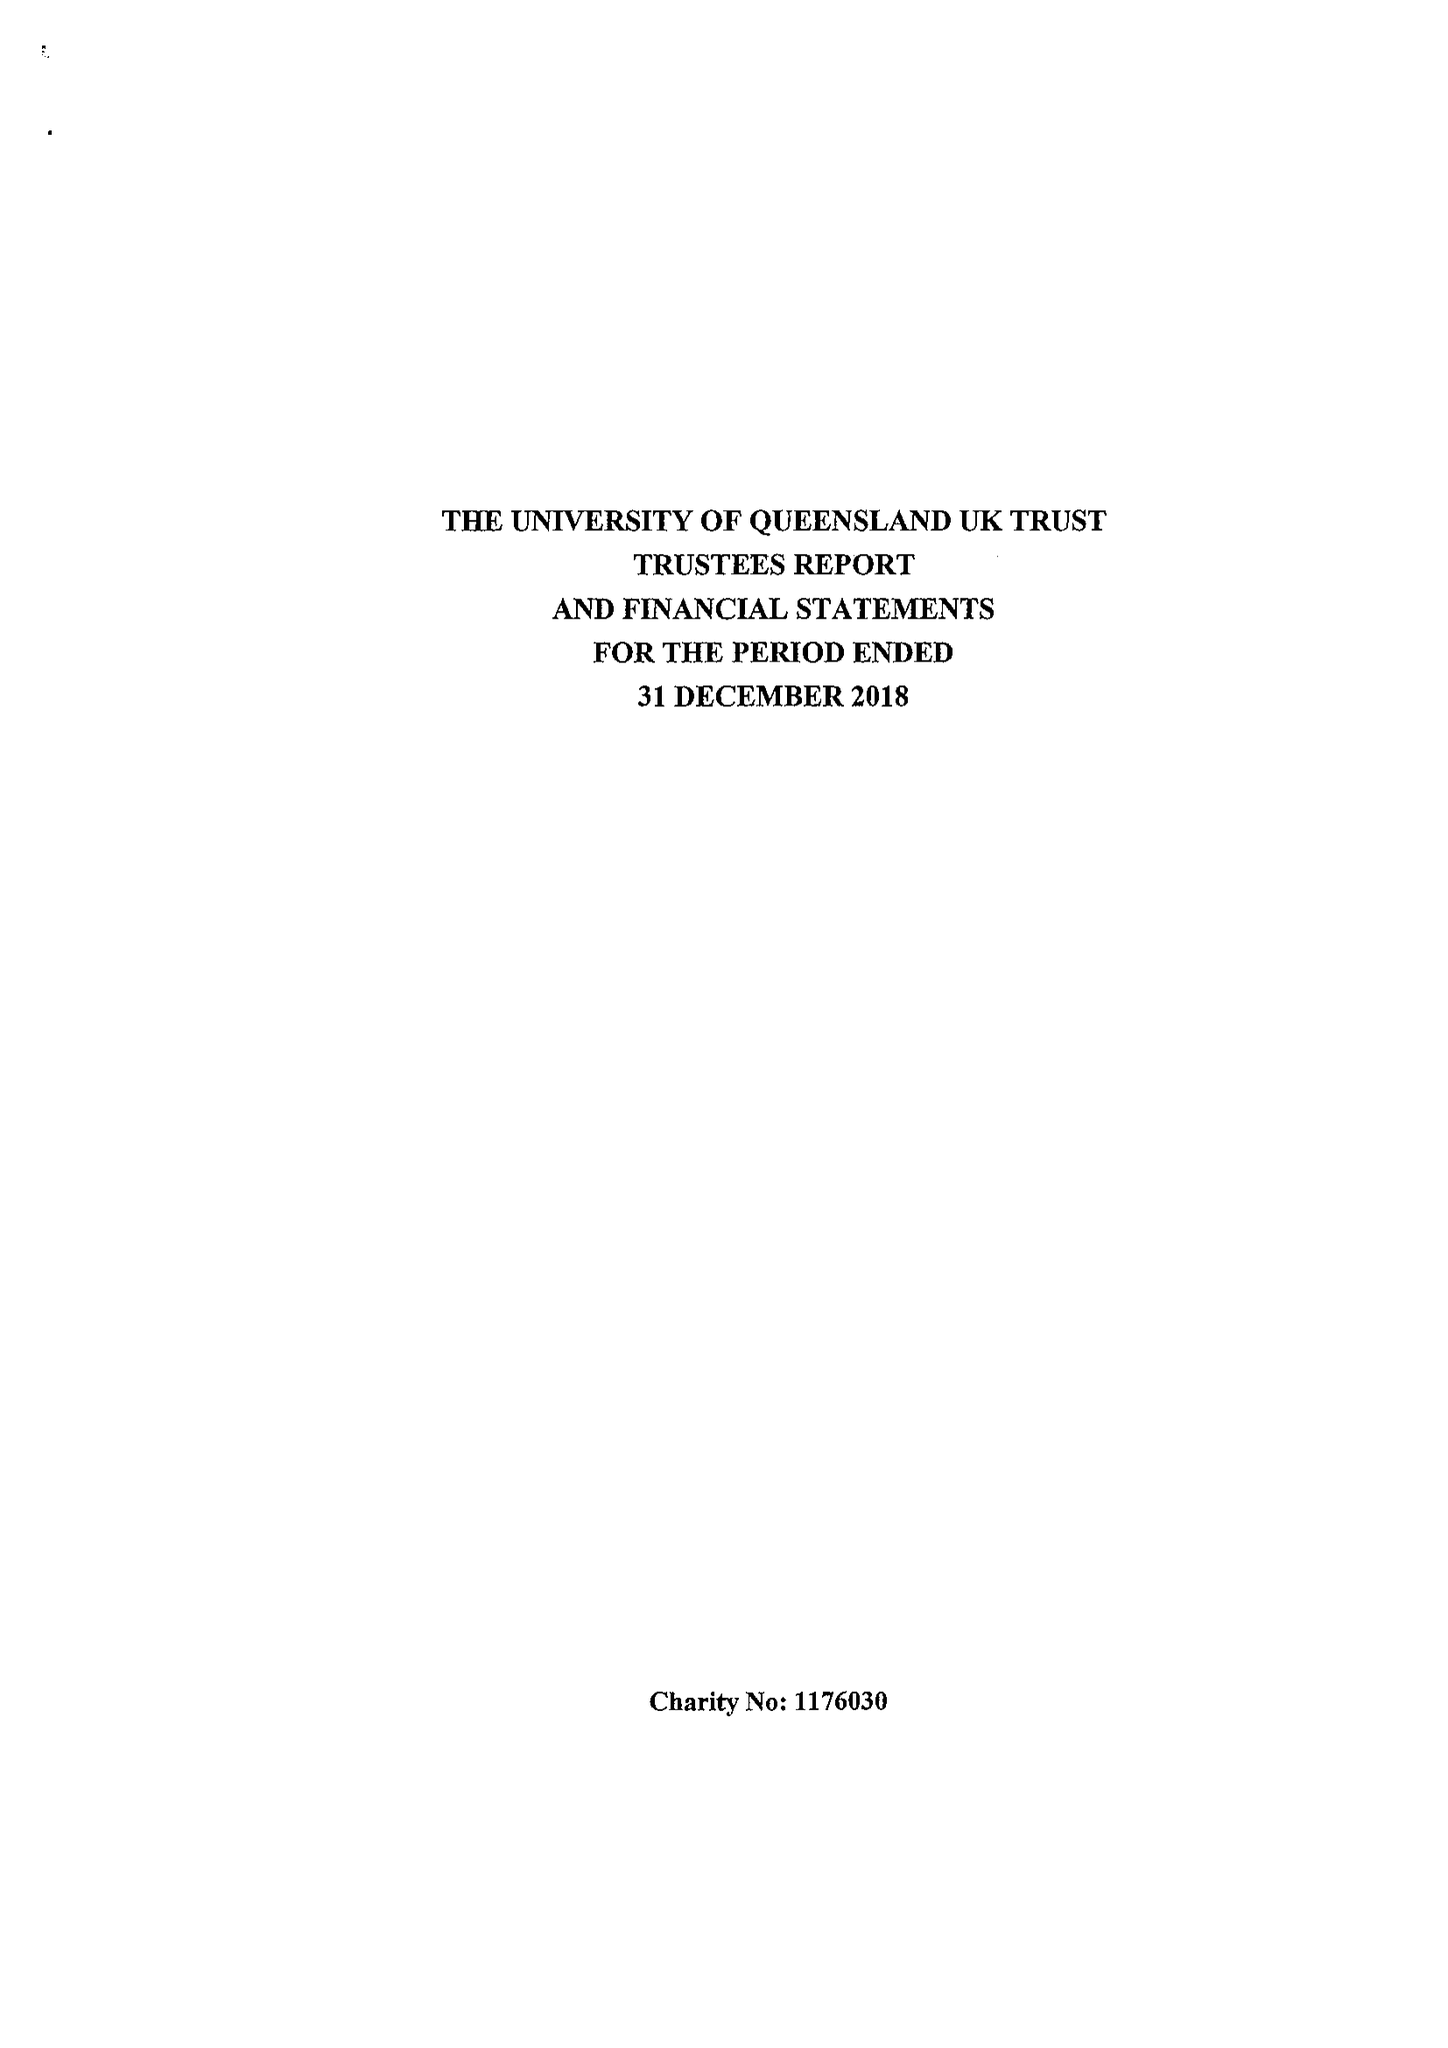What is the value for the charity_number?
Answer the question using a single word or phrase. 1176030 